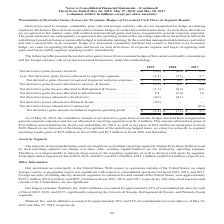According to Conagra Brands's financial document, What is the use of derivatives? manage commodity price risk. The document states: "Derivatives used to manage commodity price risk and foreign currency risk are not designated for hedge accounting..." Also, What does the table show us? the net derivative gains (losses) from economic hedges of forecasted commodity consumption and the foreign currency risk of certain forecasted transactions. The document states: "The following table presents the net derivative gains (losses) from economic hedges of forecasted commodity consumption and the foreign currency risk ..." Also, What were the net derivative losses allocated to Foodservice in 2018 and 2019, respectively? The document shows two values: (0.6) and (0.1) (in millions). From the document: "Net derivative losses allocated to Foodservice . (0.6) (0.1) — derivative losses allocated to Foodservice . (0.6) (0.1) —..." Also, can you calculate: What is the percentage change in net derivative gains (losses) included in segment operating profit in 2019 compared to 2017? To answer this question, I need to perform calculations using the financial data. The calculation is: (-1.8-5.7)/5.7 , which equals -131.58 (percentage). This is based on the information: "gains (losses) allocated to reporting segments . (1.8) (7.1) 5.7 es) allocated to reporting segments . (1.8) (7.1) 5.7..." The key data points involved are: 1.8, 5.7. Also, can you calculate: What is the average net derivative gains (losses) allocated to Grocery & Snacks from 2017 to 2019? To answer this question, I need to perform calculations using the financial data. The calculation is: (-2.1+0.2+3.4)/3 , which equals 0.5 (in millions). This is based on the information: ") allocated to Grocery & Snacks . $ (2.1) $ 0.2 $ 3.4 losses) allocated to Grocery & Snacks . $ (2.1) $ 0.2 $ 3.4 gains (losses) allocated to Grocery & Snacks . $ (2.1) $ 0.2 $ 3.4..." The key data points involved are: 0.2, 2.1, 3.4. Also, can you calculate: What are the total net derivative losses allocated to Foodservice, Pinnacle Foods, as well as Commercial in 2019? Based on the calculation: (-0.6)+(-0.8) , the result is -1.4 (in millions). This is based on the information: "ative gains (losses) incurred . $ (3.6) $ (0.9) $ 0.6 allocated to Refrigerated & Frozen . (1.1) (0.3) 0.8..." The key data points involved are: 0.6, 0.8. 